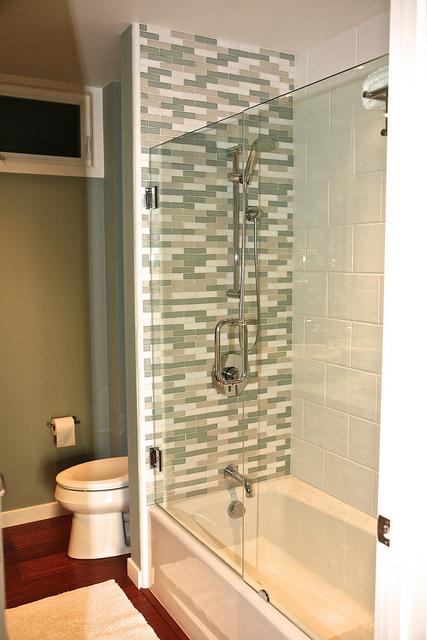What room of the house is this?
Keep it brief. Bathroom. What is the floor made of?
Answer briefly. Wood. Is the bathtub filled with water?
Answer briefly. No. Is the image high or low resolution?
Concise answer only. High. 